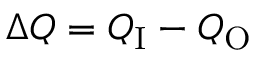<formula> <loc_0><loc_0><loc_500><loc_500>\Delta Q = Q _ { I } - Q _ { O }</formula> 